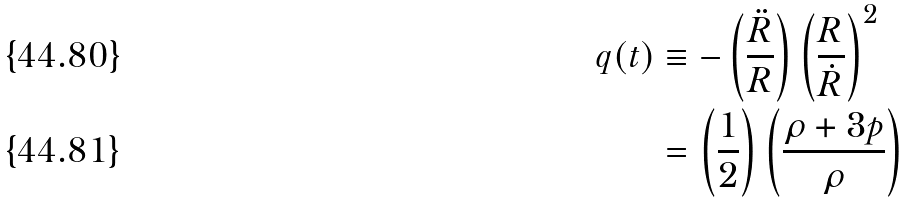<formula> <loc_0><loc_0><loc_500><loc_500>q ( t ) & \equiv - \left ( \frac { \ddot { R } } { R } \right ) \left ( \frac { R } { \dot { R } } \right ) ^ { 2 } \\ & = \left ( \frac { 1 } { 2 } \right ) \left ( \frac { \rho + 3 p } { \rho } \right )</formula> 